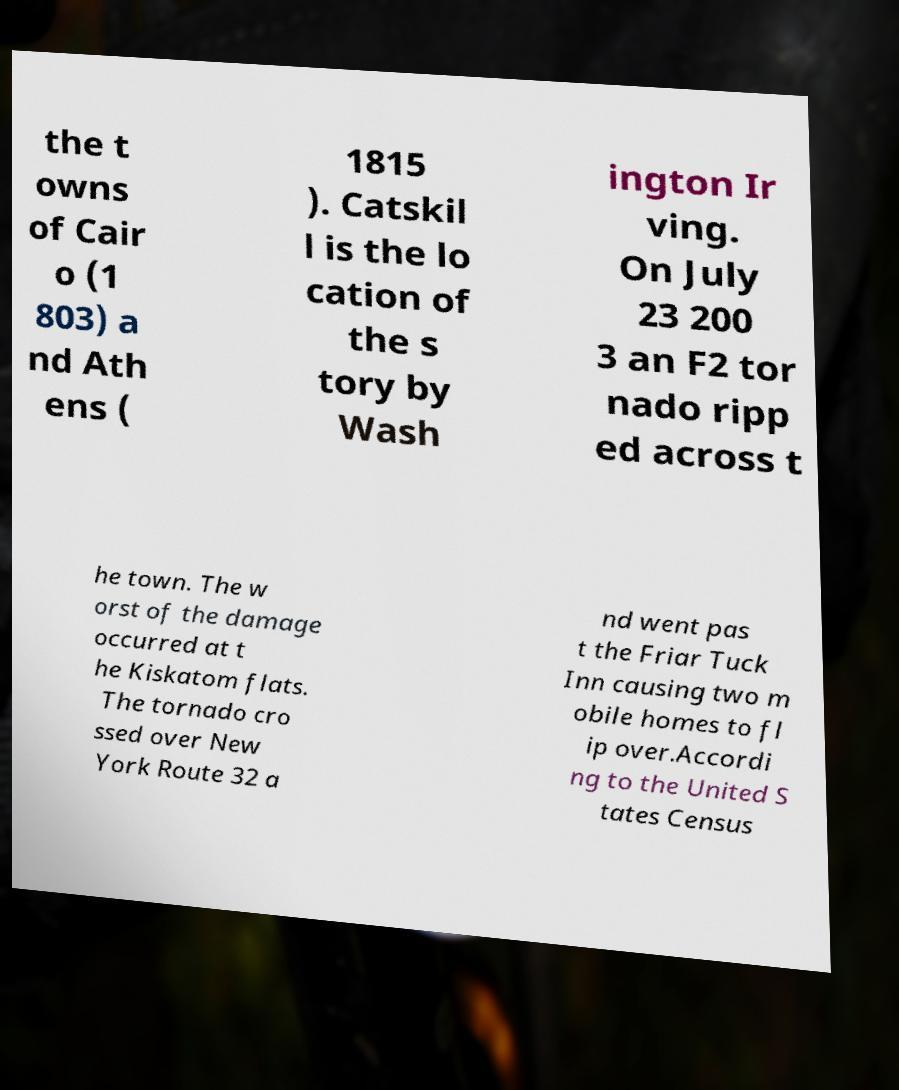Can you read and provide the text displayed in the image?This photo seems to have some interesting text. Can you extract and type it out for me? the t owns of Cair o (1 803) a nd Ath ens ( 1815 ). Catskil l is the lo cation of the s tory by Wash ington Ir ving. On July 23 200 3 an F2 tor nado ripp ed across t he town. The w orst of the damage occurred at t he Kiskatom flats. The tornado cro ssed over New York Route 32 a nd went pas t the Friar Tuck Inn causing two m obile homes to fl ip over.Accordi ng to the United S tates Census 